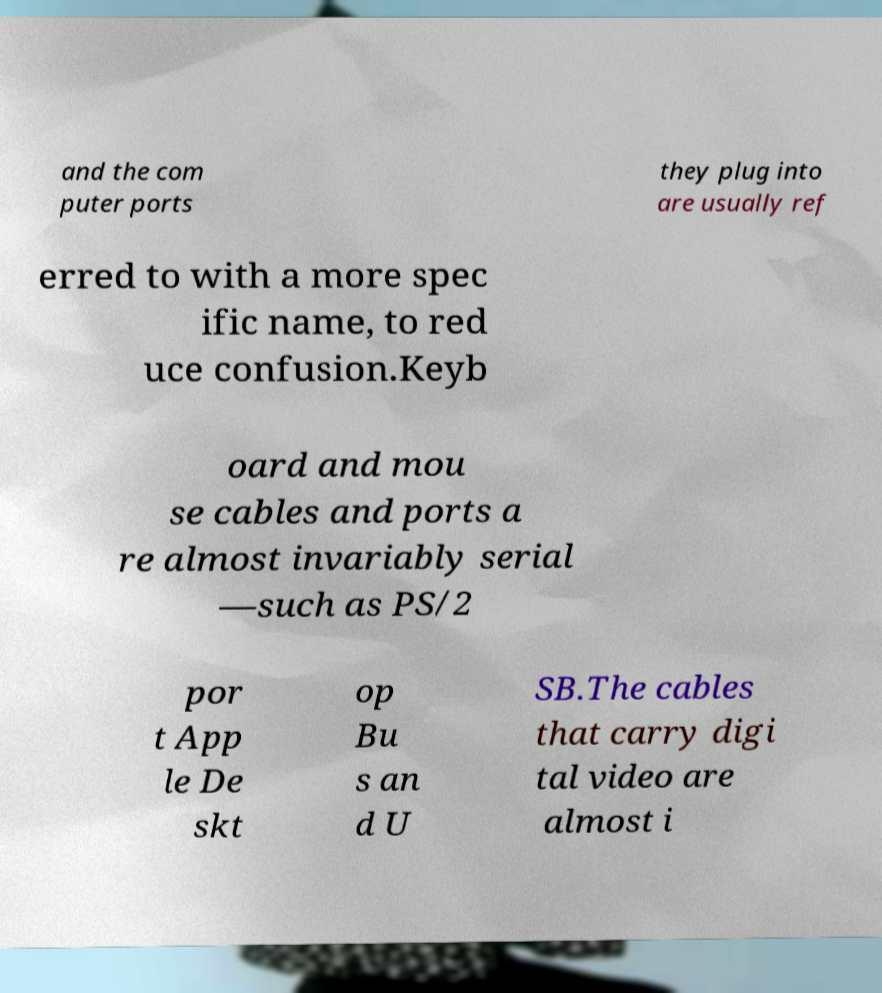What messages or text are displayed in this image? I need them in a readable, typed format. and the com puter ports they plug into are usually ref erred to with a more spec ific name, to red uce confusion.Keyb oard and mou se cables and ports a re almost invariably serial —such as PS/2 por t App le De skt op Bu s an d U SB.The cables that carry digi tal video are almost i 